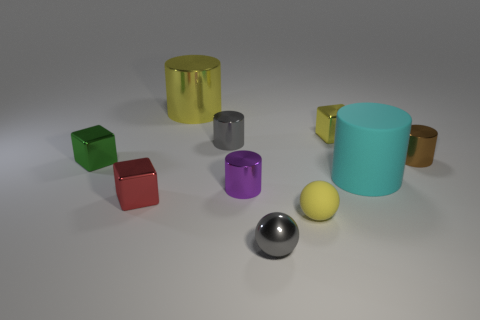Subtract all purple cylinders. How many cylinders are left? 4 Subtract all large cyan cylinders. How many cylinders are left? 4 Subtract all green cylinders. Subtract all blue spheres. How many cylinders are left? 5 Subtract all balls. How many objects are left? 8 Add 7 big yellow things. How many big yellow things exist? 8 Subtract 1 purple cylinders. How many objects are left? 9 Subtract all tiny yellow matte cylinders. Subtract all red objects. How many objects are left? 9 Add 5 large yellow objects. How many large yellow objects are left? 6 